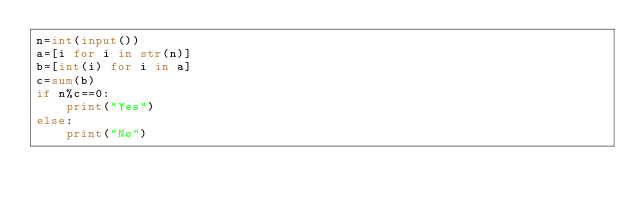Convert code to text. <code><loc_0><loc_0><loc_500><loc_500><_Python_>n=int(input())
a=[i for i in str(n)]
b=[int(i) for i in a]
c=sum(b)
if n%c==0:
    print("Yes")
else:
    print("No")</code> 